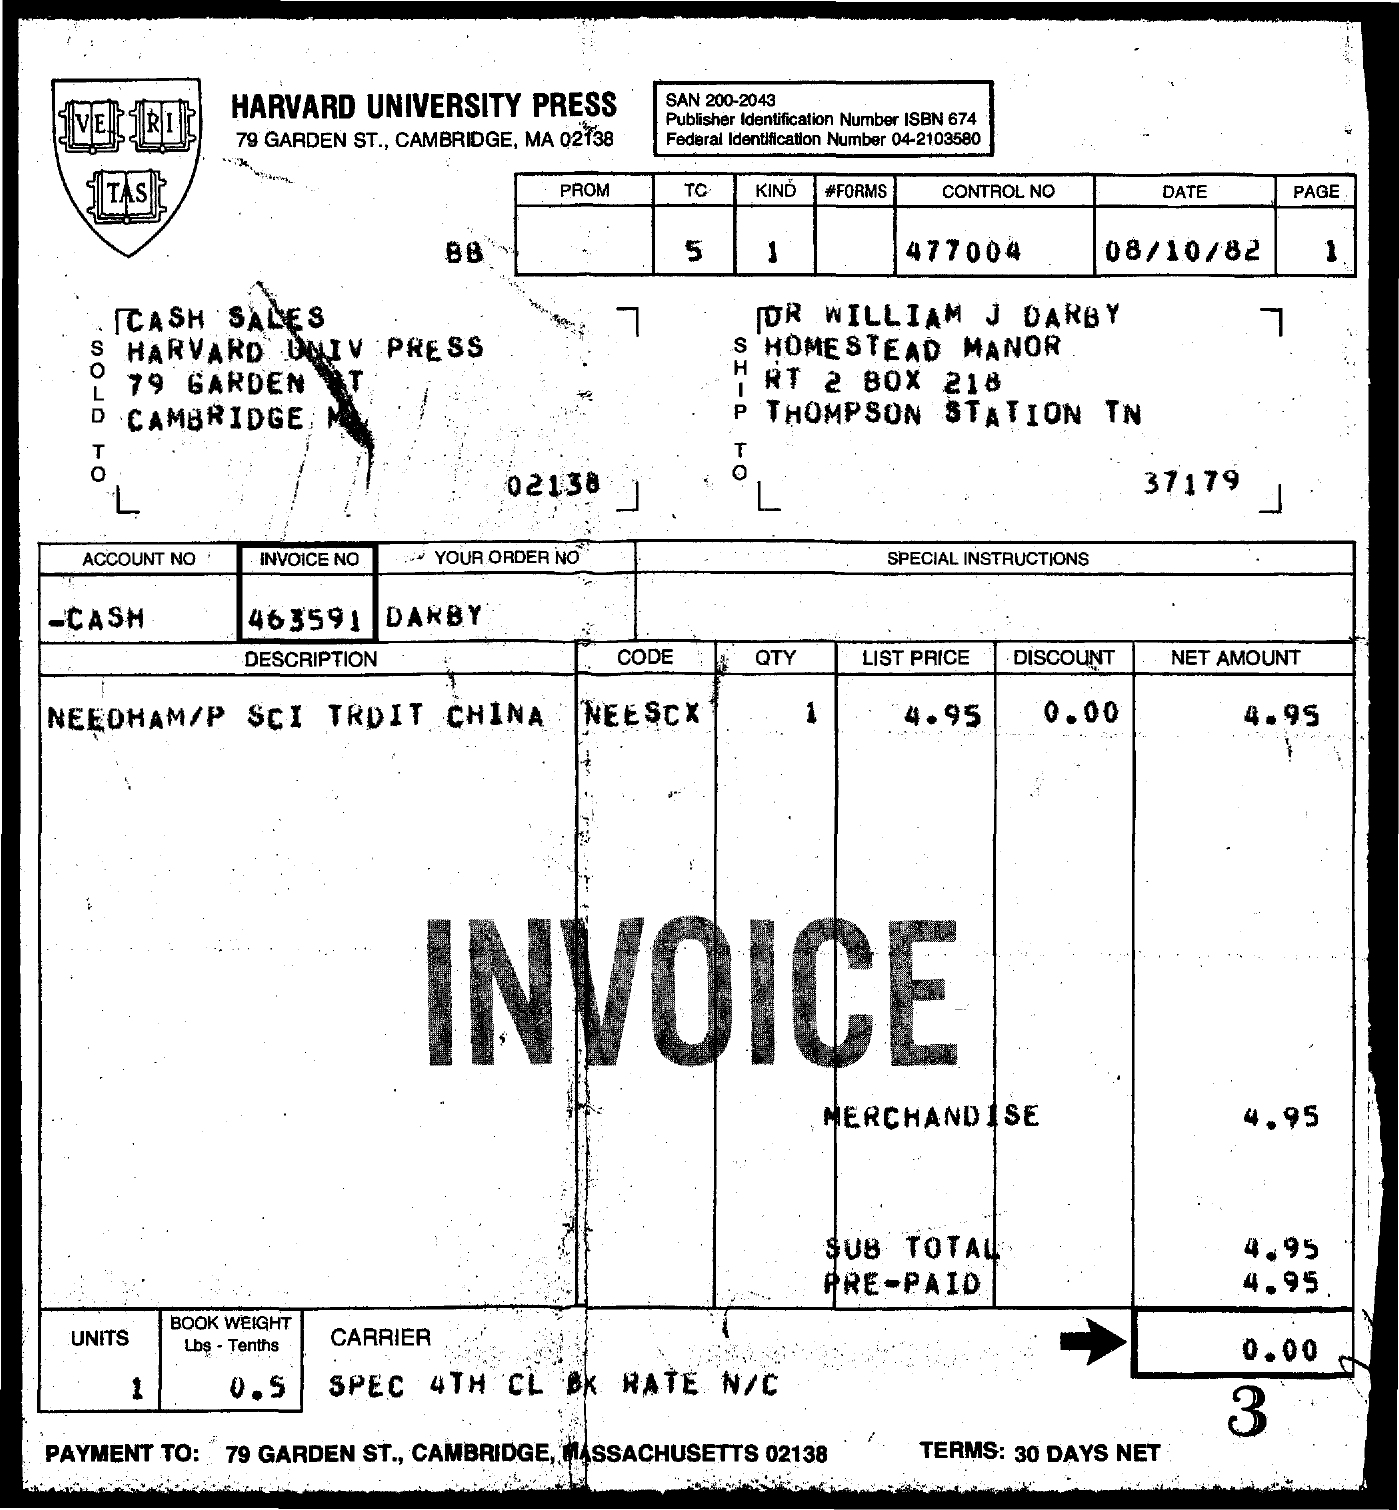What is the control No given in the invoice?
Keep it short and to the point. 477004. What is the date mentioned in the invoice?
Provide a succinct answer. 08/10/82. What is the page no mentioned in the invoice?
Provide a short and direct response. 1. What is the invoice no given in the form?
Your answer should be compact. 463591. What is the net amount for merchandise given in the invoice?
Offer a terse response. 4.95. What is the Book weight (Lbs-Tenths) mentioned in the invoice form?
Make the answer very short. 0.5. How many units are given as per the invoice?
Ensure brevity in your answer.  1. 